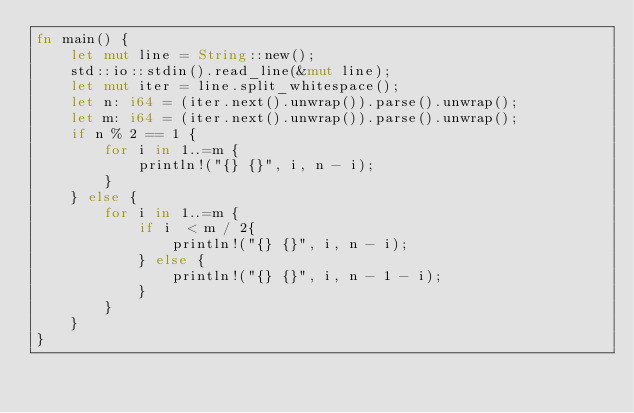Convert code to text. <code><loc_0><loc_0><loc_500><loc_500><_Rust_>fn main() {
    let mut line = String::new();
    std::io::stdin().read_line(&mut line);
    let mut iter = line.split_whitespace();
    let n: i64 = (iter.next().unwrap()).parse().unwrap();
    let m: i64 = (iter.next().unwrap()).parse().unwrap();
    if n % 2 == 1 {
        for i in 1..=m {
            println!("{} {}", i, n - i);
        }
    } else {
        for i in 1..=m {
            if i  < m / 2{
                println!("{} {}", i, n - i);
            } else {
                println!("{} {}", i, n - 1 - i);
            }
        }
    }
}
</code> 